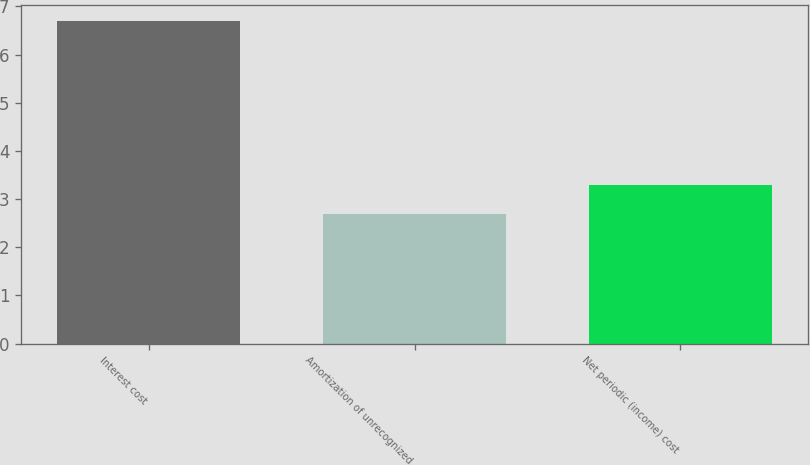<chart> <loc_0><loc_0><loc_500><loc_500><bar_chart><fcel>Interest cost<fcel>Amortization of unrecognized<fcel>Net periodic (income) cost<nl><fcel>6.7<fcel>2.7<fcel>3.3<nl></chart> 